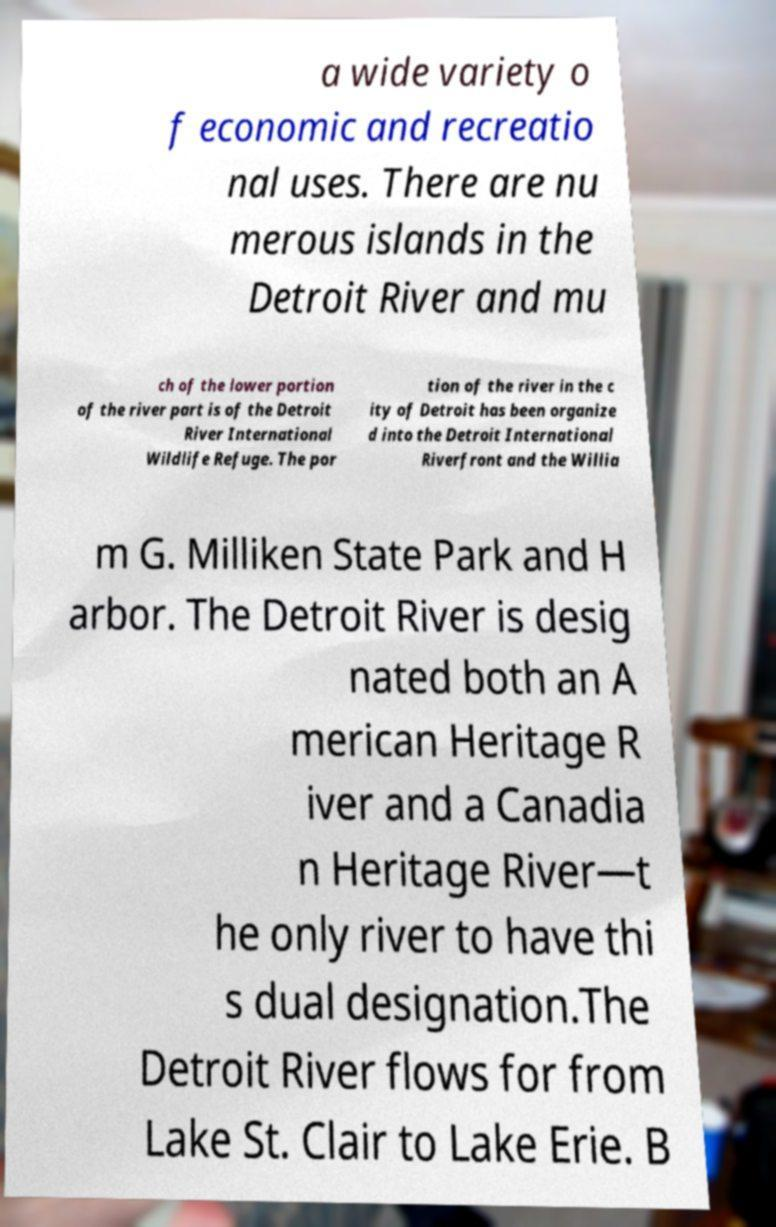Please read and relay the text visible in this image. What does it say? a wide variety o f economic and recreatio nal uses. There are nu merous islands in the Detroit River and mu ch of the lower portion of the river part is of the Detroit River International Wildlife Refuge. The por tion of the river in the c ity of Detroit has been organize d into the Detroit International Riverfront and the Willia m G. Milliken State Park and H arbor. The Detroit River is desig nated both an A merican Heritage R iver and a Canadia n Heritage River—t he only river to have thi s dual designation.The Detroit River flows for from Lake St. Clair to Lake Erie. B 